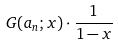Convert formula to latex. <formula><loc_0><loc_0><loc_500><loc_500>G ( a _ { n } ; x ) \cdot \frac { 1 } { 1 - x }</formula> 